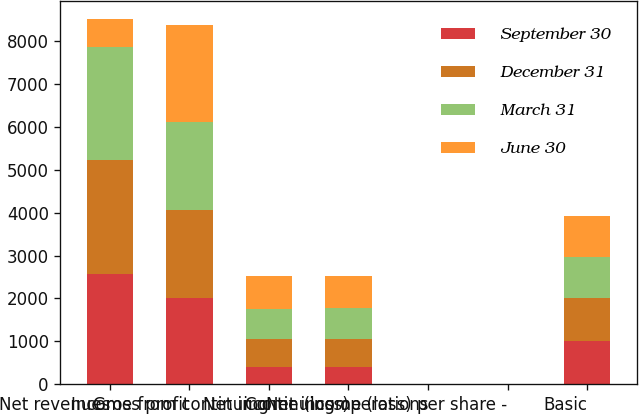Convert chart. <chart><loc_0><loc_0><loc_500><loc_500><stacked_bar_chart><ecel><fcel>Net revenues<fcel>Gross profit<fcel>Income from continuing<fcel>Net income (loss)<fcel>Continuing operations<fcel>Net income (loss) per share -<fcel>Basic<nl><fcel>September 30<fcel>2580<fcel>2021<fcel>407<fcel>407<fcel>0.4<fcel>0.4<fcel>1010<nl><fcel>December 31<fcel>2640<fcel>2043<fcel>638<fcel>642<fcel>0.64<fcel>0.64<fcel>992<nl><fcel>March 31<fcel>2649<fcel>2041<fcel>720<fcel>721<fcel>0.74<fcel>0.73<fcel>974<nl><fcel>June 30<fcel>642<fcel>2259<fcel>763<fcel>760<fcel>0.81<fcel>0.8<fcel>945<nl></chart> 